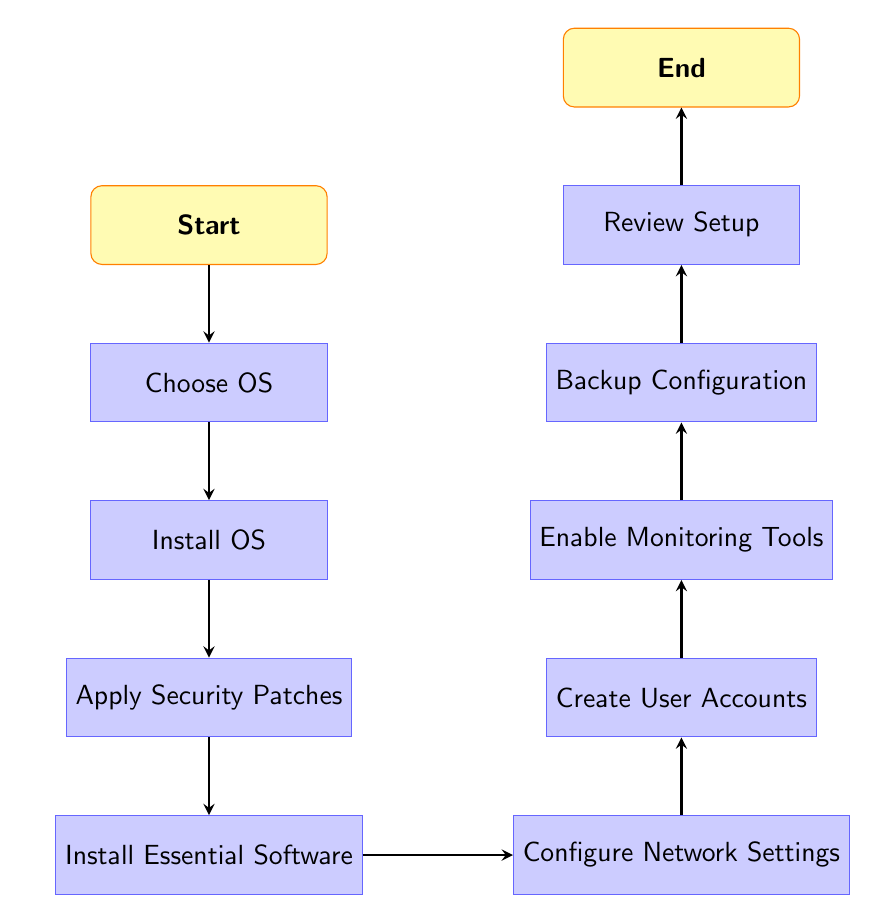What is the starting point of the flow chart? The flow chart begins with the node labeled "Start", which indicates the initiation of the server setup process.
Answer: Start What is the last step in the process? The final step in the process is represented by the node titled "End", which signifies the completion of the server setup.
Answer: End How many total process steps are there in this flow chart? There are 9 process steps indicated in the flow chart, from "Choose OS" to "Review Setup", excluding the "Start" and "End" nodes.
Answer: 9 Which step follows the installation of the operating system? The step that follows "Install OS" is "Apply Security Patches", as it is the next node in the flow after the OS installation.
Answer: Apply Security Patches What two processes are connected directly after "Install Essential Software"? After "Install Essential Software", there is a direct connection to "Configure Network Settings", meaning they are sequentially linked in the flow of the setup process.
Answer: Configure Network Settings What is required immediately after "Create User Accounts"? The next action after "Create User Accounts" is to "Enable Monitoring Tools", indicating that monitoring is prioritized right after user configuration.
Answer: Enable Monitoring Tools Which task must be completed before the server setup can be reviewed? Before the "Review Setup" step can occur, it is mandatory to complete the "Backup Configuration" task to ensure that all configurations are secured.
Answer: Backup Configuration How does the diagram flow from the "Choose OS" step to the "End"? The flow proceeds sequentially from "Choose OS" to "Install OS", then to "Apply Security Patches", and continues through each successive task until it reaches the "End", following a linear path.
Answer: Sequentially through each step Which task comes before the network settings configuration? The task that comes immediately before "Configure Network Settings" is "Install Essential Software", reflecting the order in which these tasks must be completed.
Answer: Install Essential Software 